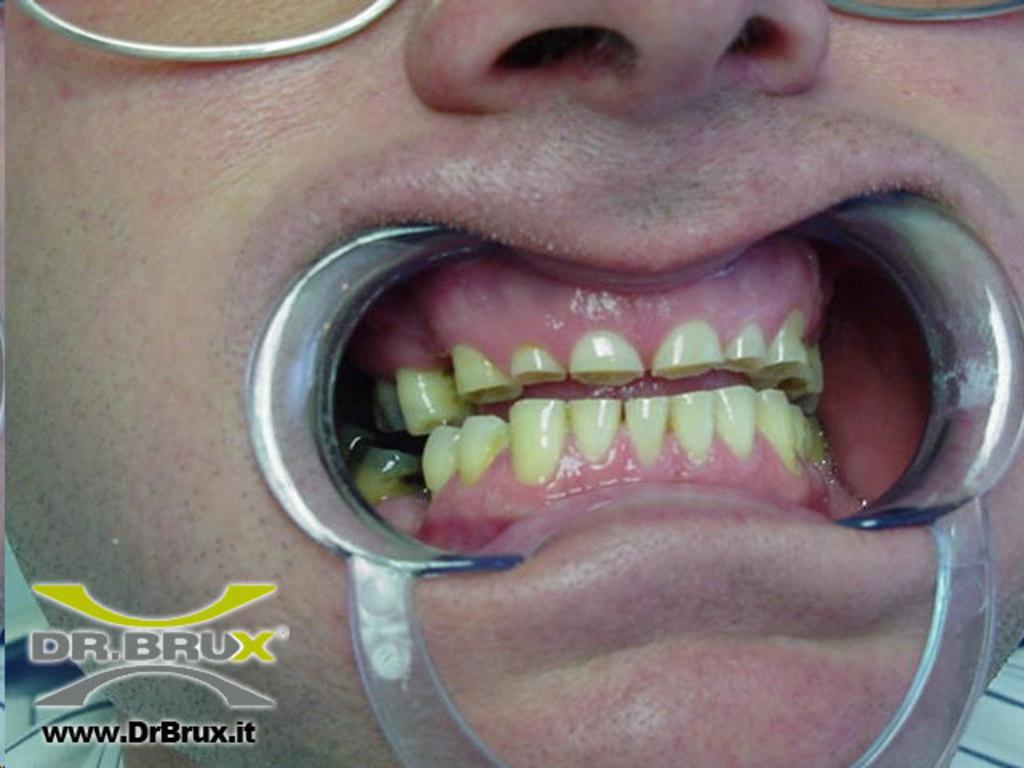What is the main subject of the image? The main subject of the image is teeth. What is happening to the teeth in the image? The teeth are being operated on using dentistry equipment. What type of hook is being used to decorate the cake in the image? There is no cake or hook present in the image; it features teeth being operated on using dentistry equipment. 